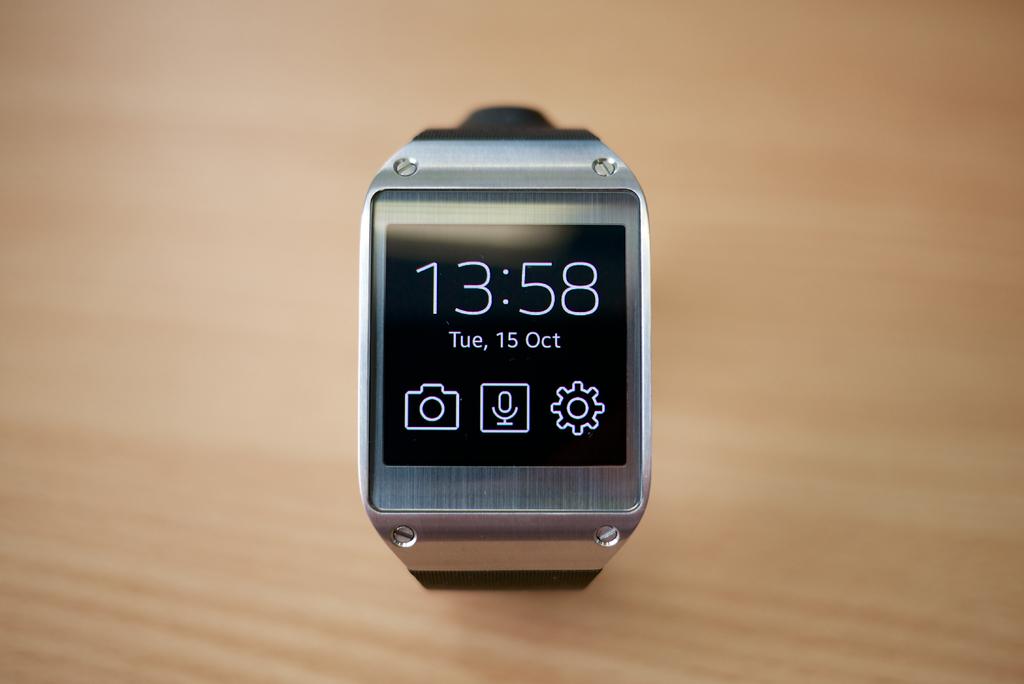What is the date on the watch?
Offer a terse response. October 15. What is the time on the watch?
Keep it short and to the point. 13:58. 